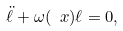<formula> <loc_0><loc_0><loc_500><loc_500>\ddot { \ell } + \omega ( \ x ) \ell = 0 ,</formula> 